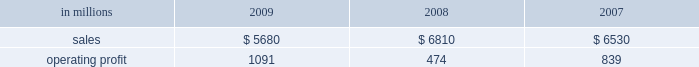Mill in the fourth quarter of 2008 .
This compares with 635000 tons of total downtime in 2008 of which 305000 tons were lack-of-order downtime .
Printing papers in millions 2009 2008 2007 .
North american printing papers net sales in 2009 were $ 2.8 billion compared with $ 3.4 billion in 2008 and $ 3.5 billion in 2007 .
Operating earnings in 2009 were $ 746 million ( $ 307 million excluding alter- native fuel mixture credits and plant closure costs ) compared with $ 405 million ( $ 435 million excluding shutdown costs for a paper machine ) in 2008 and $ 415 million in 2007 .
Sales volumes decreased sig- nificantly in 2009 compared with 2008 reflecting weak customer demand and reduced production capacity resulting from the shutdown of a paper machine at the franklin mill in december 2008 and the conversion of the bastrop mill to pulp production in june 2008 .
Average sales price realizations were lower reflecting slight declines for uncoated freesheet paper in domestic markets and significant declines in export markets .
Margins were also unfavorably affected by a higher proportion of shipments to lower-margin export markets .
Input costs , however , were favorable due to lower wood and chemical costs and sig- nificantly lower energy costs .
Freight costs were also lower .
Planned maintenance downtime costs in 2009 were comparable with 2008 .
Operating costs were favorable , reflecting cost control efforts and strong machine performance .
Lack-of-order downtime increased to 525000 tons in 2009 , including 120000 tons related to the shutdown of a paper machine at our franklin mill in the 2008 fourth quarter , from 135000 tons in 2008 .
Operating earnings in 2009 included $ 671 million of alternative fuel mixture cred- its , $ 223 million of costs associated with the shutdown of our franklin mill and $ 9 million of other shutdown costs , while operating earnings in 2008 included $ 30 million of costs for the shutdown of a paper machine at our franklin mill .
Looking ahead to 2010 , first-quarter sales volumes are expected to increase slightly from fourth-quarter 2009 levels .
Average sales price realizations should be higher , reflecting the full-quarter impact of sales price increases announced in the fourth quarter for converting and envelope grades of uncoated free- sheet paper and an increase in prices to export markets .
However , input costs for wood , energy and chemicals are expected to continue to increase .
Planned maintenance downtime costs should be lower and operating costs should be favorable .
Brazil ian papers net sales for 2009 of $ 960 mil- lion increased from $ 950 million in 2008 and $ 850 million in 2007 .
Operating profits for 2009 were $ 112 million compared with $ 186 million in 2008 and $ 174 million in 2007 .
Sales volumes increased in 2009 compared with 2008 for both paper and pulp reflect- ing higher export shipments .
Average sales price realizations were lower due to strong competitive pressures in the brazilian domestic market in the second half of the year , lower export prices and unfavorable foreign exchange rates .
Margins were unfavorably affected by a higher proportion of lower margin export sales .
Input costs for wood and chem- icals were favorable , but these benefits were partially offset by higher energy costs .
Planned maintenance downtime costs were lower , and operating costs were also favorable .
Earnings in 2009 were adversely impacted by unfavorable foreign exchange effects .
Entering 2010 , sales volumes are expected to be seasonally lower compared with the fourth quarter of 2009 .
Profit margins are expected to be slightly higher reflecting a more favorable geographic sales mix and improving sales price realizations in export markets , partially offset by higher planned main- tenance outage costs .
European papers net sales in 2009 were $ 1.3 bil- lion compared with $ 1.7 billion in 2008 and $ 1.5 bil- lion in 2007 .
Operating profits in 2009 of $ 92 million ( $ 115 million excluding expenses associated with the closure of the inverurie mill ) compared with $ 39 mil- lion ( $ 146 million excluding a charge to reduce the carrying value of the fixed assets at the inverurie , scotland mill to their estimated realizable value ) in 2008 and $ 171 million in 2007 .
Sales volumes in 2009 were lower than in 2008 primarily due to reduced sales of uncoated freesheet paper following the closure of the inverurie mill in 2009 .
Average sales price realizations decreased significantly in 2009 across most of western europe , but margins increased in poland and russia reflecting the effect of local currency devaluations .
Input costs were favorable as lower wood costs , particularly in russia , were only partially offset by higher energy costs in poland and higher chemical costs .
Planned main- tenance downtime costs were higher in 2009 than in 2008 , while manufacturing operating costs were lower .
Operating profits in 2009 also reflect favorable foreign exchange impacts .
Looking ahead to 2010 , sales volumes are expected to decline from strong 2009 fourth-quarter levels despite solid customer demand .
Average sales price realizations are expected to increase over the quar- ter , primarily in eastern europe , as price increases .
North american printing papers net sales where what percent of total printing paper sales in 2008? 
Computations: ((3.4 * 1000) / 6810)
Answer: 0.49927. 